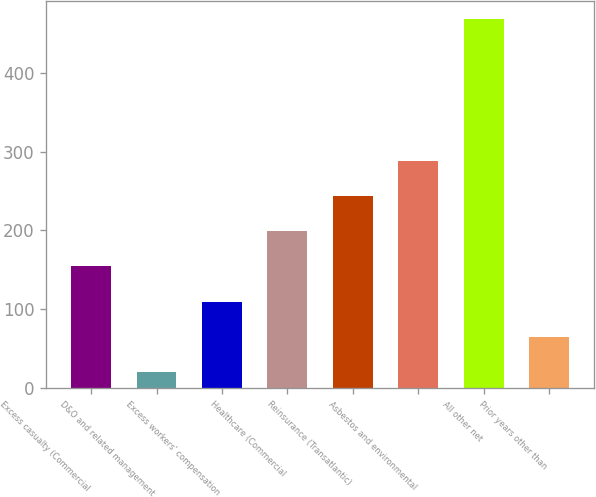<chart> <loc_0><loc_0><loc_500><loc_500><bar_chart><fcel>Excess casualty (Commercial<fcel>D&O and related management<fcel>Excess workers' compensation<fcel>Healthcare (Commercial<fcel>Reinsurance (Transatlantic)<fcel>Asbestos and environmental<fcel>All other net<fcel>Prior years other than<nl><fcel>154.4<fcel>20<fcel>109.6<fcel>199.2<fcel>244<fcel>288.8<fcel>468<fcel>64.8<nl></chart> 